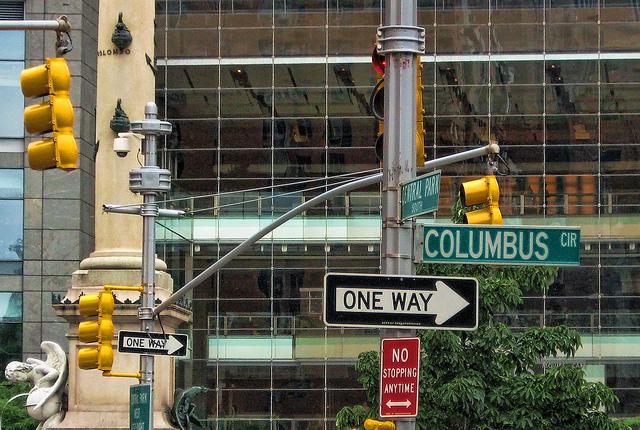How many ways is Columbus Cir?
Quick response, please. 1. How many signs are in this scene?
Quick response, please. 6. What city is this photo taken in?
Short answer required. New york. 